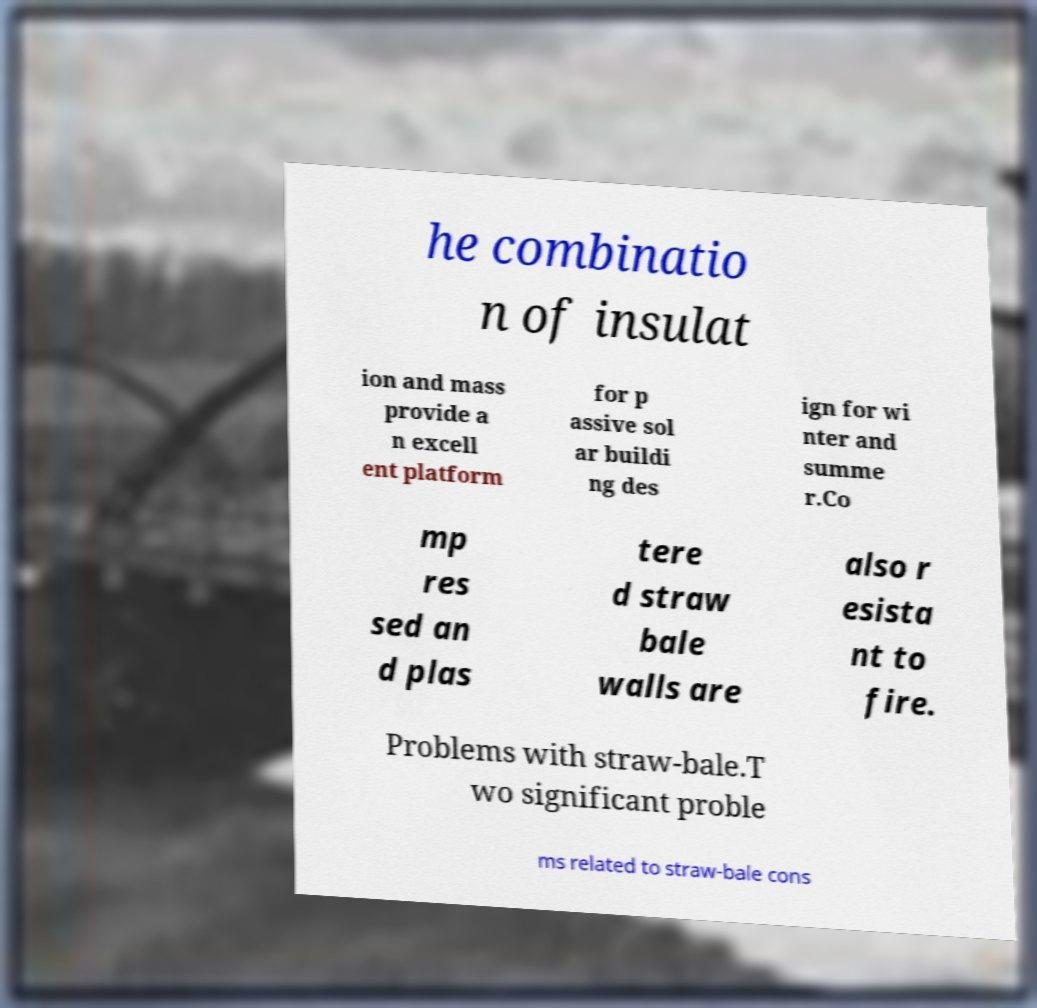Please read and relay the text visible in this image. What does it say? he combinatio n of insulat ion and mass provide a n excell ent platform for p assive sol ar buildi ng des ign for wi nter and summe r.Co mp res sed an d plas tere d straw bale walls are also r esista nt to fire. Problems with straw-bale.T wo significant proble ms related to straw-bale cons 